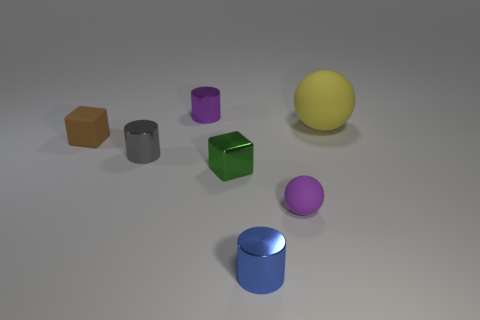Is there anything else that has the same size as the yellow rubber object?
Ensure brevity in your answer.  No. Does the tiny ball have the same color as the cylinder behind the big yellow rubber object?
Provide a short and direct response. Yes. Are there more tiny shiny objects on the left side of the blue object than large gray cylinders?
Your answer should be compact. Yes. What number of blue shiny things are left of the purple thing that is right of the cylinder that is in front of the small matte ball?
Your response must be concise. 1. Is the shape of the tiny purple rubber thing that is right of the tiny gray cylinder the same as  the large thing?
Offer a terse response. Yes. What material is the tiny cylinder that is to the right of the small green metal block?
Provide a short and direct response. Metal. There is a object that is both behind the small green shiny block and in front of the brown cube; what is its shape?
Make the answer very short. Cylinder. What is the green thing made of?
Your answer should be very brief. Metal. What number of cubes are either tiny green metal things or blue objects?
Provide a short and direct response. 1. Are the tiny brown object and the small purple cylinder made of the same material?
Offer a very short reply. No. 